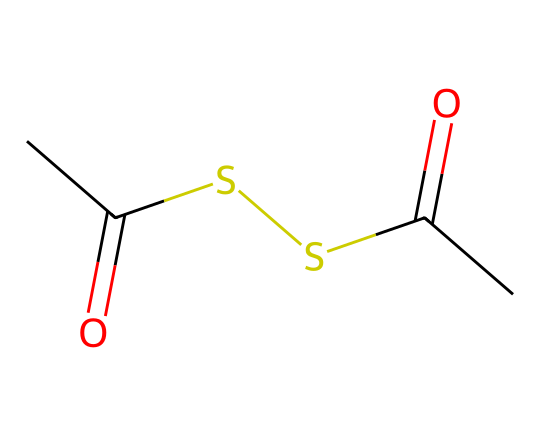What is the total number of carbon atoms in this compound? The SMILES representation CC(=O)SSC(=O)C indicates there are three 'C' characters, signifying three carbon atoms.
Answer: three How many sulfur atoms are present in the molecule? In the SMILES, there are two 'S' characters indicating that there are two sulfur atoms in the structure.
Answer: two What functional groups are identified in this chemical? By analyzing the structure represented in the SMILES, there are two carbonyls (C=O) and one thioether (S) indicating two functional groups: thioketone and thioether.
Answer: thioketone, thioether What is the oxidation state of sulfur in this compound? The sulfur atoms are bonded to carbon and also part of a carbonyl group (C=O), where sulfur is usually in a lower oxidation state. In this instance, it's generally assigned an oxidation state of -2 for thiol components and can vary due to the carbonyl bonds. However, for simplification we can specify -2 based on the predominant bonding.
Answer: -2 How does the presence of sulfur affect the properties of ceramics? The incorporation of organosulfur compounds in ceramics can enhance toughness and improve thermal stability due to sulfur's ability to form covalent bonds that can act as a cross-linking agent in ceramic materials.
Answer: enhanced toughness, thermal stability What type of bonding is prevalent in this organosulfur compound? The compound displays covalent bonding characteristics, mainly through the shared pairs of electrons between the carbon and sulfur atoms and also between carbon and oxygen in the carbonyl groups.
Answer: covalent bonding 